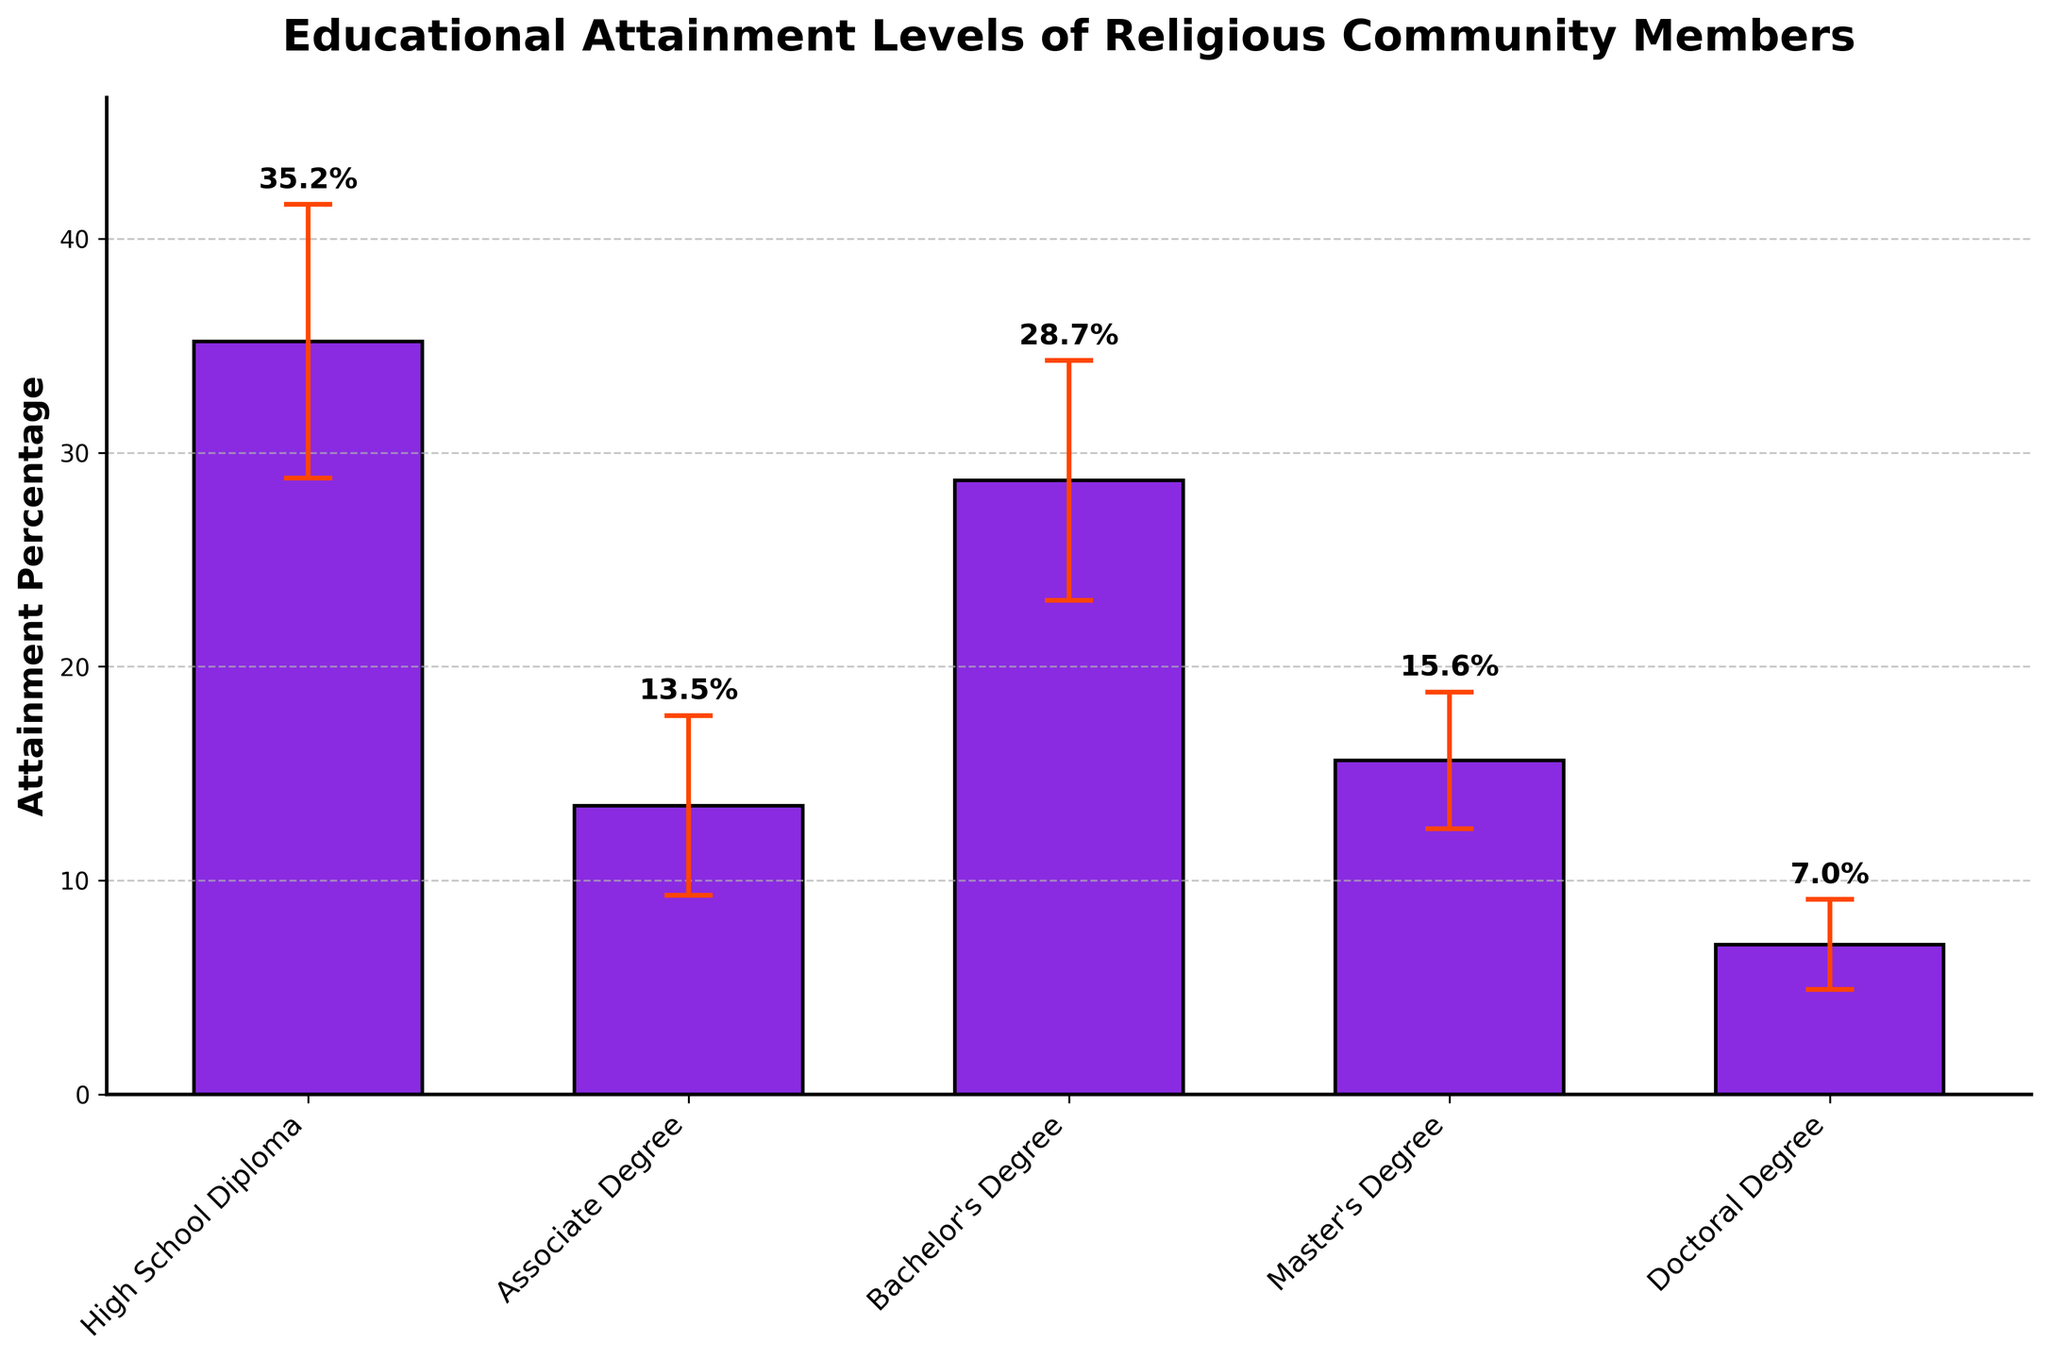which education level has the highest mean attainment percentage? The highest bar represents the highest mean attainment percentage. The bar for High School Diploma is the tallest.
Answer: High School Diploma what is the title of the chart? The title is positioned at the top center of the chart.
Answer: Educational Attainment Levels of Religious Community Members which education level has the lowest mean attainment percentage? The shortest bar represents the lowest mean attainment percentage. The bar for Doctoral Degree is the shortest.
Answer: Doctoral Degree how many education levels are displayed in the chart? Count the number of bars on the chart. There are five distinct bars.
Answer: 5 what is the mean attainment percentage for a bachelor's degree? Look at the label above the bar corresponding to Bachelor's Degree.
Answer: 28.7% what's the difference in mean attainment between a master's degree and an associate degree? Find the mean attainment percentages for both Master's Degree (15.6%) and Associate Degree (13.5%), then calculate the difference (15.6 - 13.5).
Answer: 2.1% which education level has the widest error bar? Compare the length of the vertical lines (error bars) above each bar. The High School Diploma has the longest error bar.
Answer: High School Diploma what is the maximum value displayed on the y-axis? Check the highest value marked on the y-axis. The y-axis extends to 45%.
Answer: 45% how does the error bar of a bachelor's degree compare to that of an associate degree? Compare the lengths of the error bars above the bars for Bachelor's Degree and Associate Degree. The error bar for Bachelor's Degree is longer than that for Associate Degree.
Answer: The error bar for a Bachelor's Degree is larger what is the average mean attainment percentage across all education levels? Sum the mean attainment percentages (35.2 + 13.5 + 28.7 + 15.6 + 7.0) and divide it by the number of education levels (5). 100.0 / 5 = 20.
Answer: 20% 